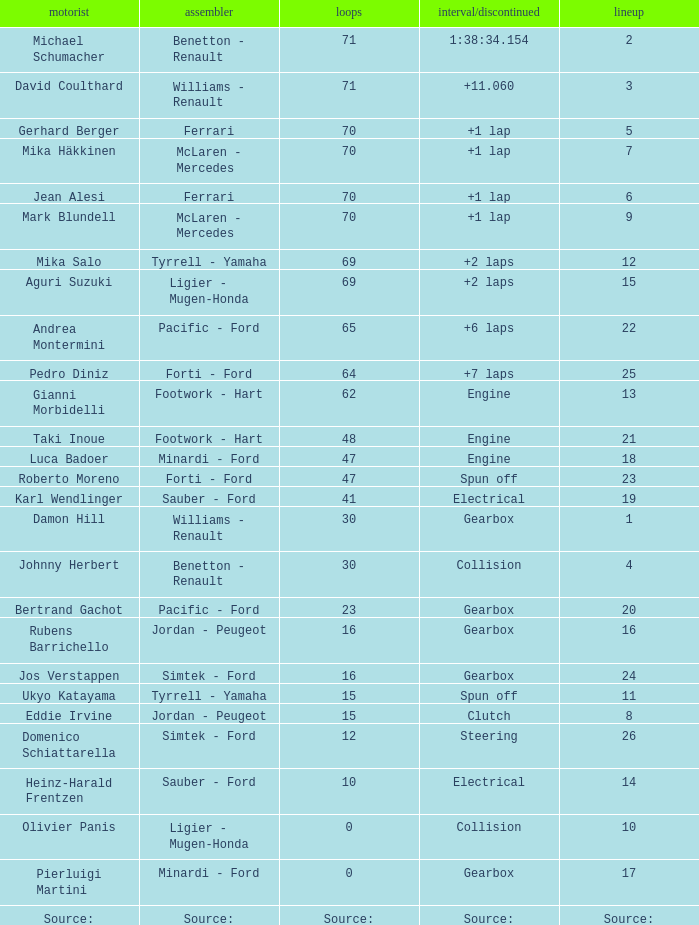How many laps were there in grid 21? 48.0. 